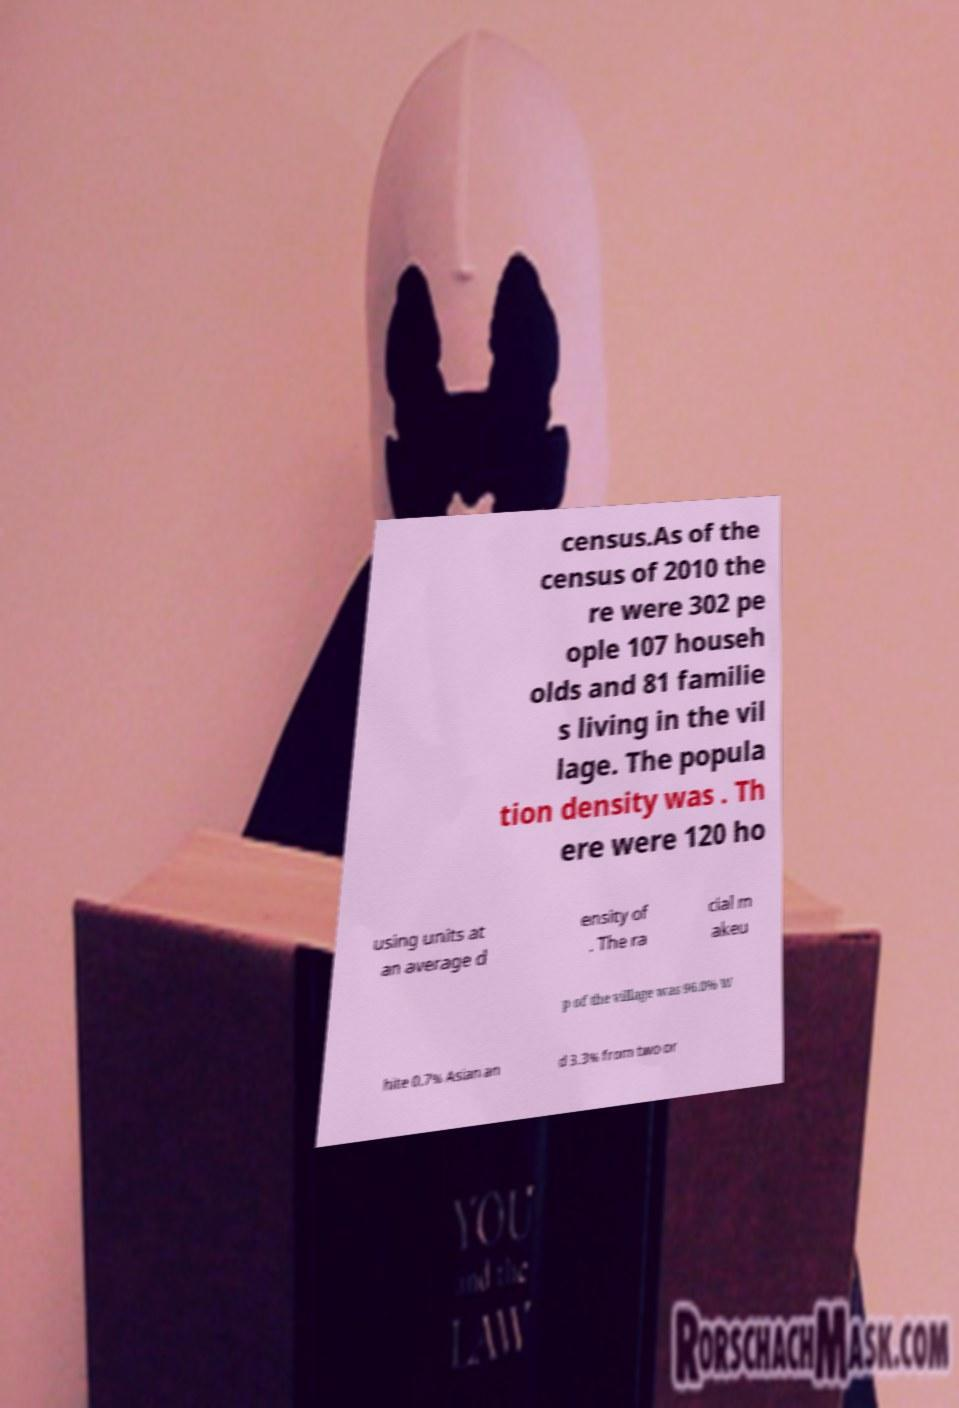Can you read and provide the text displayed in the image?This photo seems to have some interesting text. Can you extract and type it out for me? census.As of the census of 2010 the re were 302 pe ople 107 househ olds and 81 familie s living in the vil lage. The popula tion density was . Th ere were 120 ho using units at an average d ensity of . The ra cial m akeu p of the village was 96.0% W hite 0.7% Asian an d 3.3% from two or 